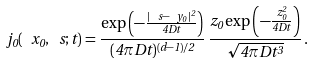Convert formula to latex. <formula><loc_0><loc_0><loc_500><loc_500>j _ { 0 } ( \ x _ { 0 } , \ s ; t ) = \frac { \exp \left ( - \frac { | \ s - \ y _ { 0 } | ^ { 2 } } { 4 D t } \right ) } { ( 4 \pi D t ) ^ { ( d - 1 ) / 2 } } \, \frac { z _ { 0 } \exp \left ( - \frac { z _ { 0 } ^ { 2 } } { 4 D t } \right ) } { \sqrt { 4 \pi D t ^ { 3 } } } \, .</formula> 